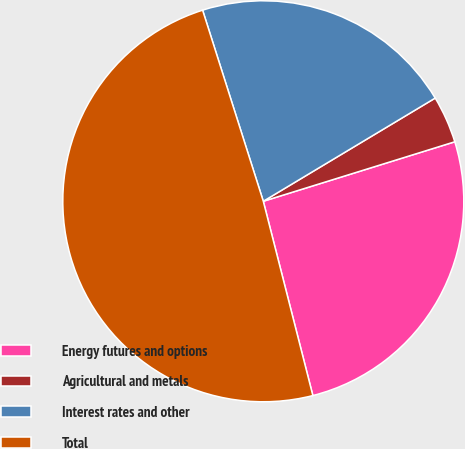Convert chart to OTSL. <chart><loc_0><loc_0><loc_500><loc_500><pie_chart><fcel>Energy futures and options<fcel>Agricultural and metals<fcel>Interest rates and other<fcel>Total<nl><fcel>25.82%<fcel>3.81%<fcel>21.29%<fcel>49.08%<nl></chart> 